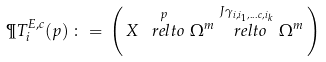<formula> <loc_0><loc_0><loc_500><loc_500>\P T ^ { E , c } _ { i } ( p ) \, \colon = \, \left ( \, X \stackrel { p } { \ r e l t o } \Omega ^ { m } \stackrel { J \gamma _ { i , i _ { 1 } , \dots c , i _ { k } } } { \ r e l t o } \Omega ^ { m } \, \right )</formula> 